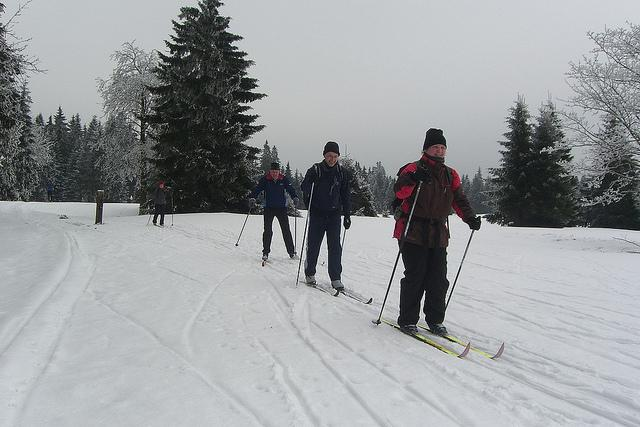What is needed for this activity? snow 